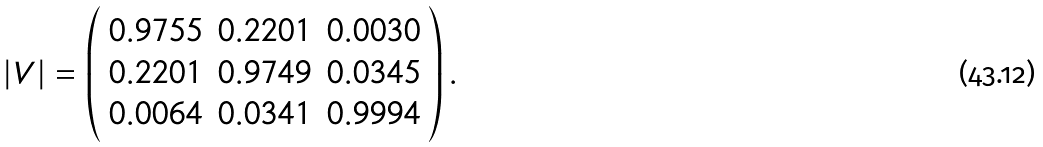<formula> <loc_0><loc_0><loc_500><loc_500>| V | = \left ( \begin{array} { c c c } 0 . 9 7 5 5 & 0 . 2 2 0 1 & 0 . 0 0 3 0 \\ 0 . 2 2 0 1 & 0 . 9 7 4 9 & 0 . 0 3 4 5 \\ 0 . 0 0 6 4 & 0 . 0 3 4 1 & 0 . 9 9 9 4 \end{array} \right ) .</formula> 